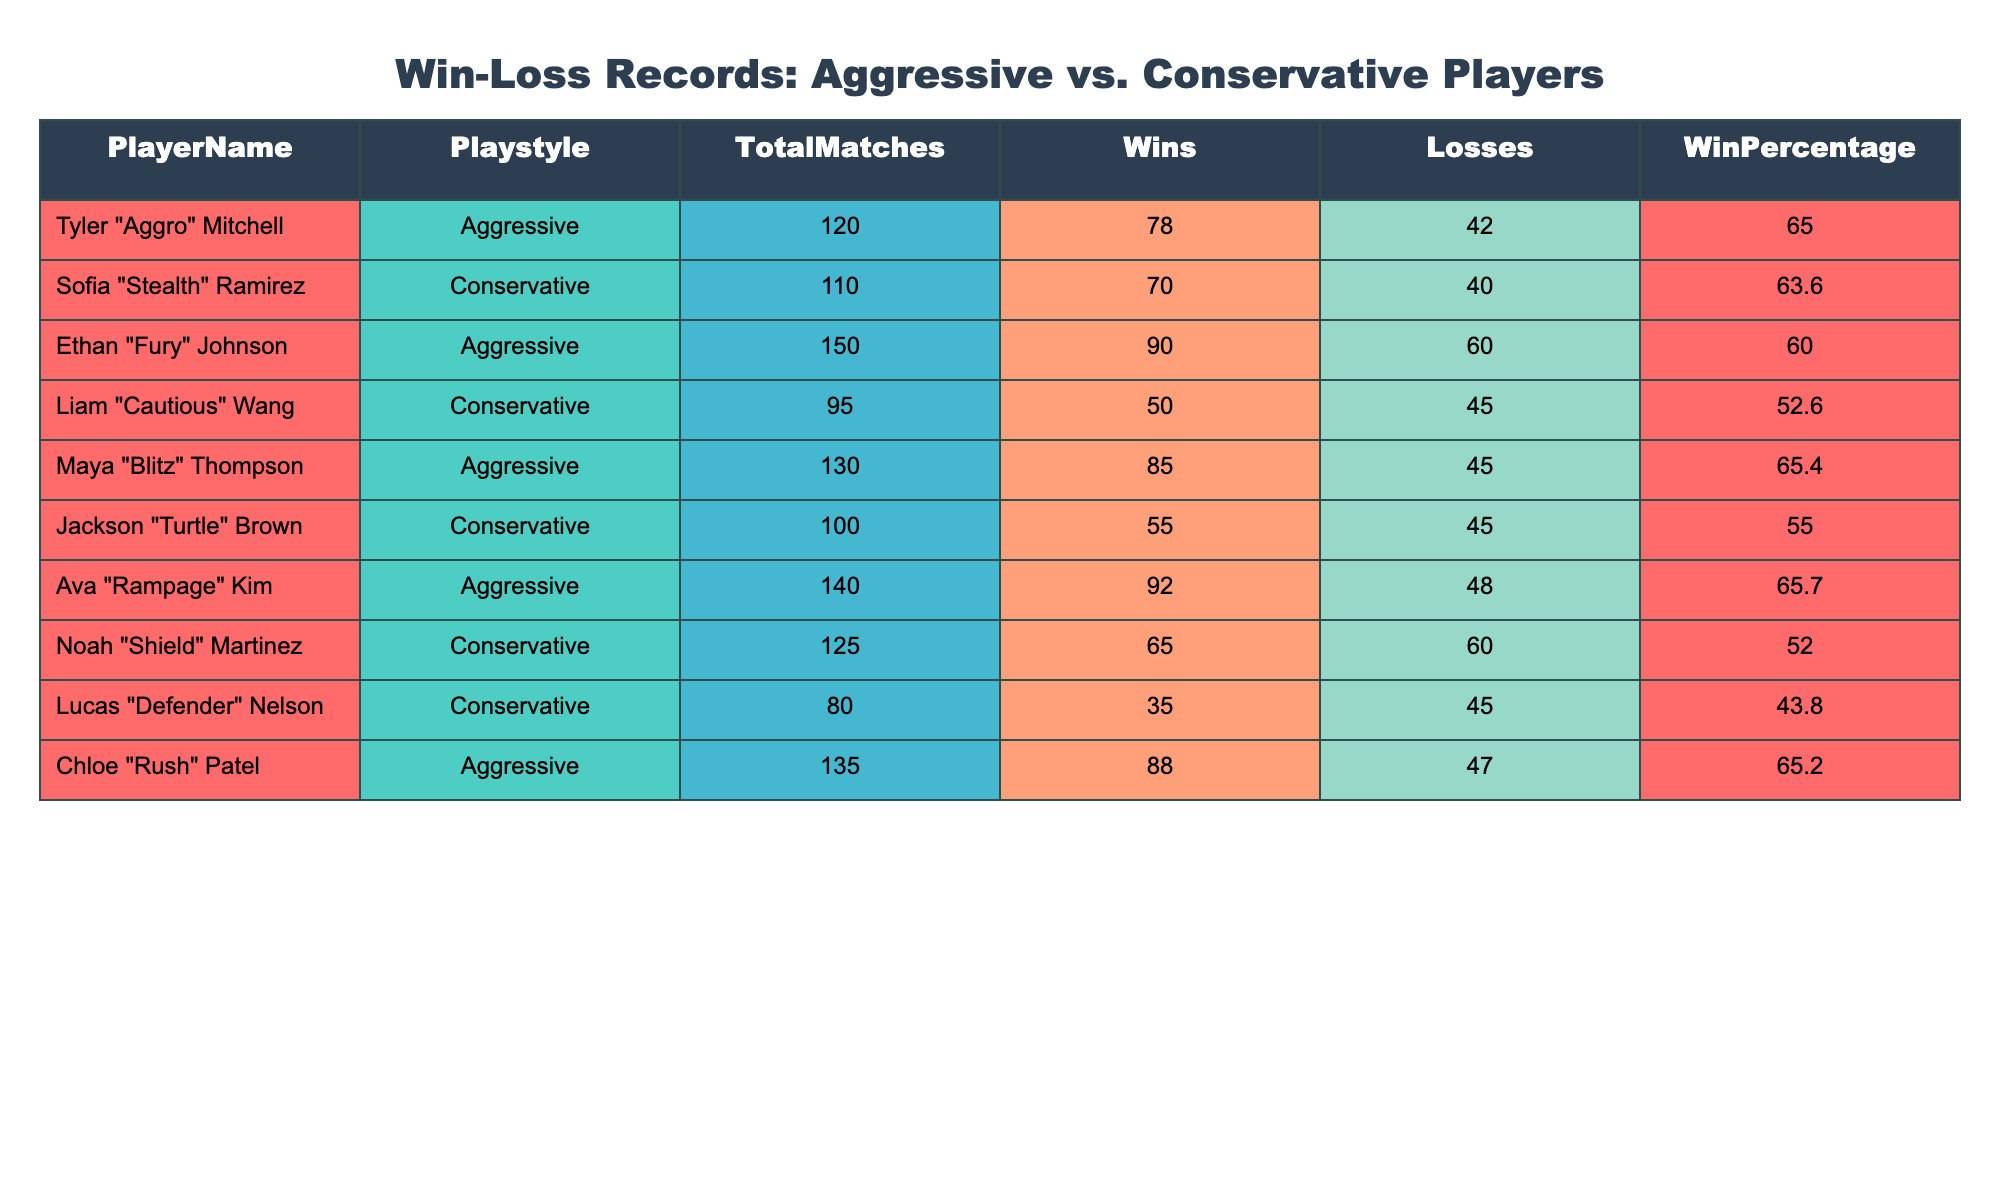What is the highest win percentage among aggressive players? Among the aggressive players, the win percentages are Tyler at 65.0, Ethan at 60.0, Maya at 65.4, Ava at 65.7, and Chloe at 65.2. The highest percentage is 65.7, achieved by Ava "Rampage" Kim.
Answer: 65.7 How many wins does Liam "Cautious" Wang have? According to the table, Liam "Cautious" Wang, who is a conservative player, has 50 wins listed in the Wins column.
Answer: 50 What is the total number of matches played by conservative players? The conservative players are Sofia, Liam, Jackson, Noah, and Lucas, with their matches being 110, 95, 100, 125, and 80 respectively. Adding these gives 110 + 95 + 100 + 125 + 80 = 510 matches total.
Answer: 510 Is the win percentage of Jackson "Turtle" Brown greater than 56%? Jackson has a win percentage of 55.0. Since 55.0 is less than 56.0, the statement is false.
Answer: No What is the difference in total matches between aggressive and conservative players? The total matches for aggressive players can be calculated as 120 + 150 + 130 + 140 + 135 = 675. The total for conservative players is 510. The difference is 675 - 510 = 165.
Answer: 165 Which aggressive player has the lowest win percentage? The win percentages for aggressive players are Tyler at 65.0, Ethan at 60.0, Maya at 65.4, Ava at 65.7, and Chloe at 65.2. The lowest among these is Ethan "Fury" Johnson with 60.0.
Answer: 60.0 How many losses do aggressive players have in total? The losses for aggressive players are 42 (Tyler) + 60 (Ethan) + 45 (Maya) + 48 (Ava) + 47 (Chloe) = 242 total losses.
Answer: 242 Is Sofia "Stealth" Ramirez the only conservative player with a win percentage above 60%? Sofia has a win percentage of 63.6, while the other conservative players have percentages of 52.6 (Liam), 55.0 (Jackson), 52.0 (Noah), and 43.8 (Lucas). Thus, she is indeed the only one above 60%.
Answer: Yes What is the average win percentage of aggressive players? The win percentages for aggressive players are 65.0, 60.0, 65.4, 65.7, and 65.2. Calculating the average: (65.0 + 60.0 + 65.4 + 65.7 + 65.2) / 5 = 63.426, which can be rounded to 63.4.
Answer: 63.4 